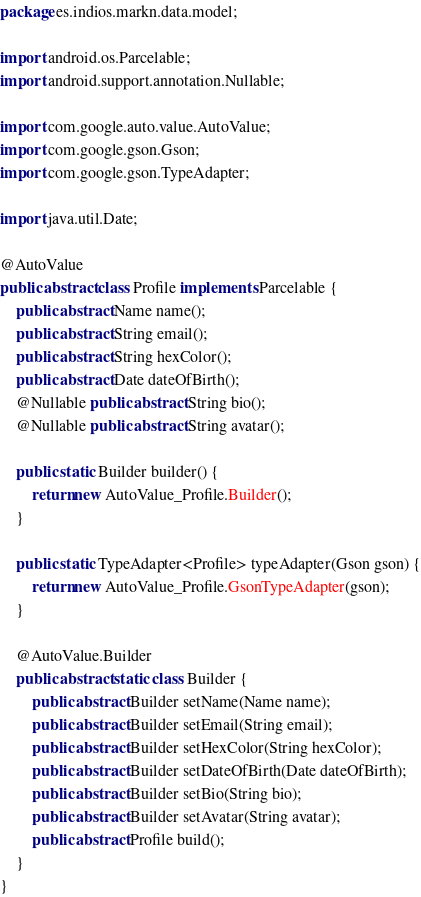Convert code to text. <code><loc_0><loc_0><loc_500><loc_500><_Java_>package es.indios.markn.data.model;

import android.os.Parcelable;
import android.support.annotation.Nullable;

import com.google.auto.value.AutoValue;
import com.google.gson.Gson;
import com.google.gson.TypeAdapter;

import java.util.Date;

@AutoValue
public abstract class Profile implements Parcelable {
    public abstract Name name();
    public abstract String email();
    public abstract String hexColor();
    public abstract Date dateOfBirth();
    @Nullable public abstract String bio();
    @Nullable public abstract String avatar();

    public static Builder builder() {
        return new AutoValue_Profile.Builder();
    }

    public static TypeAdapter<Profile> typeAdapter(Gson gson) {
        return new AutoValue_Profile.GsonTypeAdapter(gson);
    }

    @AutoValue.Builder
    public abstract static class Builder {
        public abstract Builder setName(Name name);
        public abstract Builder setEmail(String email);
        public abstract Builder setHexColor(String hexColor);
        public abstract Builder setDateOfBirth(Date dateOfBirth);
        public abstract Builder setBio(String bio);
        public abstract Builder setAvatar(String avatar);
        public abstract Profile build();
    }
}
</code> 